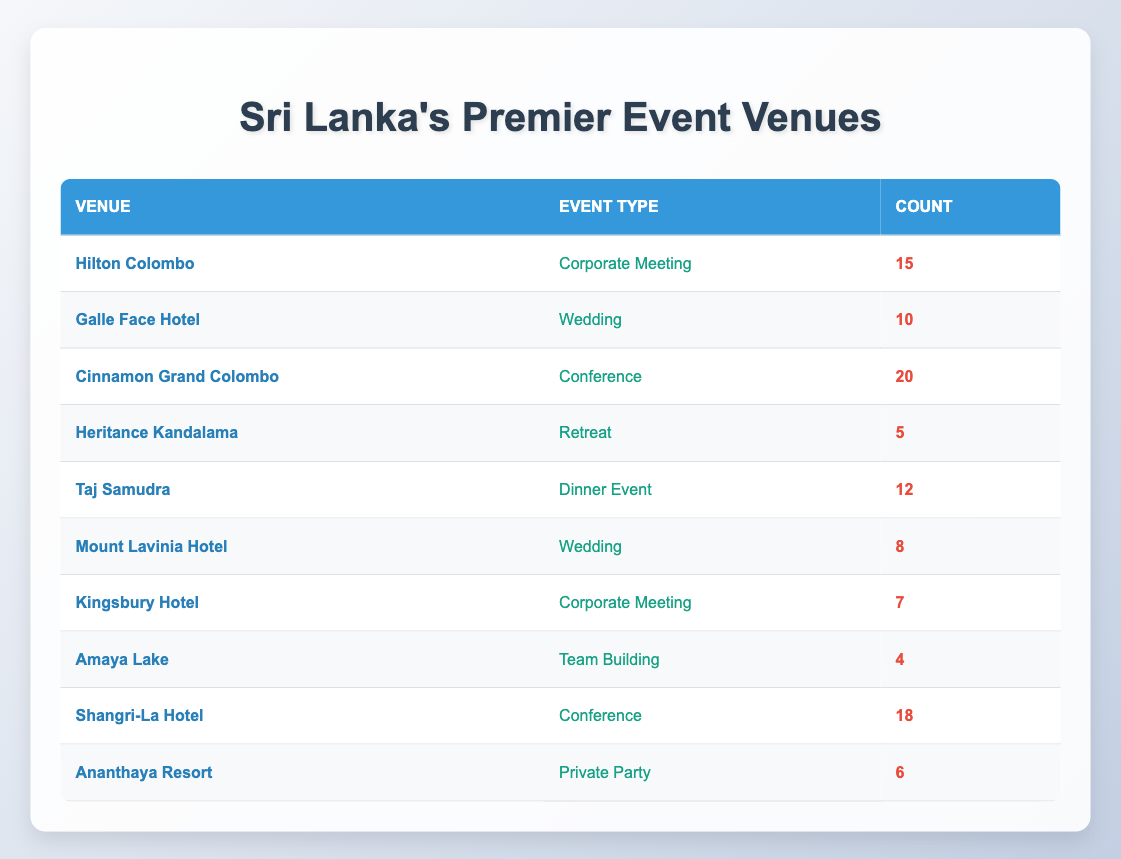What's the most popular event type at "Cinnamon Grand Colombo"? The table shows that "Cinnamon Grand Colombo" hosted "20" events, which is marked as a "Conference." Since it's the only entry for that venue, this is the most popular event type there.
Answer: Conference How many weddings were hosted in total at both "Galle Face Hotel" and "Mount Lavinia Hotel"? To calculate the total number of weddings, add the counts from both hotels: Galle Face Hotel (10) + Mount Lavinia Hotel (8) = 18.
Answer: 18 Is there any venue that has hosted more than 15 corporate meetings? Looking at the table, "Hilton Colombo" hosted 15 corporate meetings, while "Kingsbury Hotel" hosted 7. Since no venue exceeds 15 corporate meetings, the answer is no.
Answer: No What is the average number of events of all types hosted at "Hilton Colombo"? "Hilton Colombo" hosted only one type of event, which is a corporate meeting with a count of 15. Therefore, the average number of events hosted there is simply 15.
Answer: 15 Which event type had the least number of occurrences and what is that number? The event type with the least number of occurrences is "Team Building" at "Amaya Lake," which had a count of 4. This is the lowest count across all event types.
Answer: 4 Which venue hosted the most conferences? "Cinnamon Grand Colombo" with a count of 20 hosted the most conferences, followed by "Shangri-La Hotel" with 18. Therefore, the venue with the highest count is "Cinnamon Grand Colombo."
Answer: Cinnamon Grand Colombo What is the total count of private parties hosted across all venues? The only venue listed for private parties is "Ananthaya Resort," which hosted a count of 6. Thus, the total is 6.
Answer: 6 Are there more corporate meetings or weddings hosted in the venues listed? The total corporate meetings are 15 (Hilton Colombo) + 7 (Kingsbury Hotel) = 22. For weddings, the total is 10 (Galle Face Hotel) + 8 (Mount Lavinia Hotel) = 18. So, corporate meetings exceed weddings by 4.
Answer: Corporate meetings What is the difference in the number of conference events between "Cinnamon Grand Colombo" and "Shangri-La Hotel"? "Cinnamon Grand Colombo" has 20 conferences while "Shangri-La Hotel" has 18. The difference is 20 - 18 = 2.
Answer: 2 